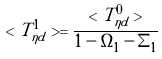Convert formula to latex. <formula><loc_0><loc_0><loc_500><loc_500>< T ^ { 1 } _ { \eta d } > = \frac { < T ^ { 0 } _ { \eta d } > } { 1 - \Omega _ { 1 } - \Sigma _ { 1 } }</formula> 